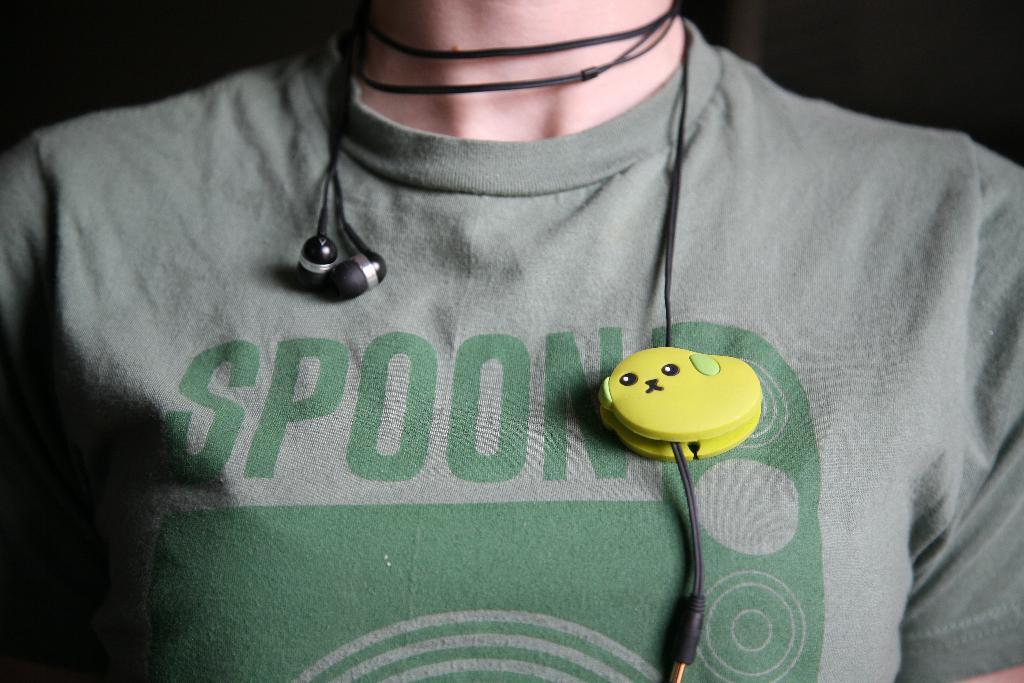Describe this image in one or two sentences. In this picture we can see a person, person wore a gray color t-shirt, we can see earphones here. 